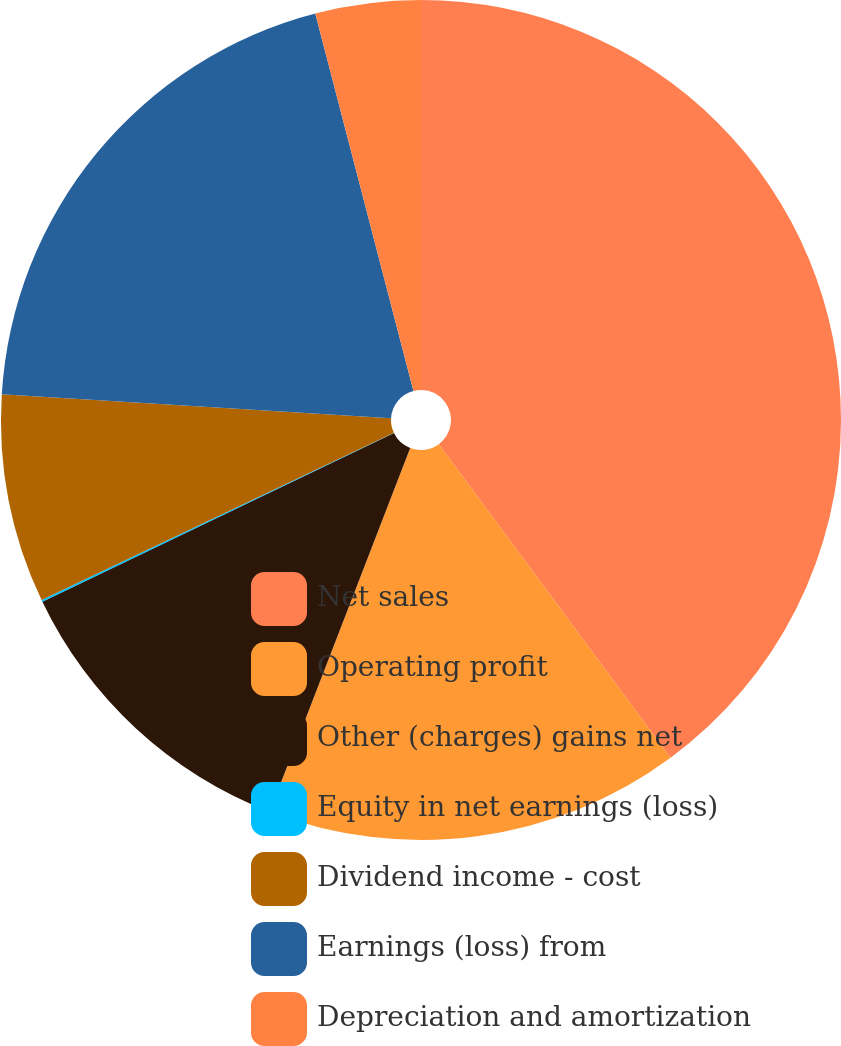Convert chart to OTSL. <chart><loc_0><loc_0><loc_500><loc_500><pie_chart><fcel>Net sales<fcel>Operating profit<fcel>Other (charges) gains net<fcel>Equity in net earnings (loss)<fcel>Dividend income - cost<fcel>Earnings (loss) from<fcel>Depreciation and amortization<nl><fcel>39.87%<fcel>15.99%<fcel>12.01%<fcel>0.07%<fcel>8.03%<fcel>19.97%<fcel>4.05%<nl></chart> 